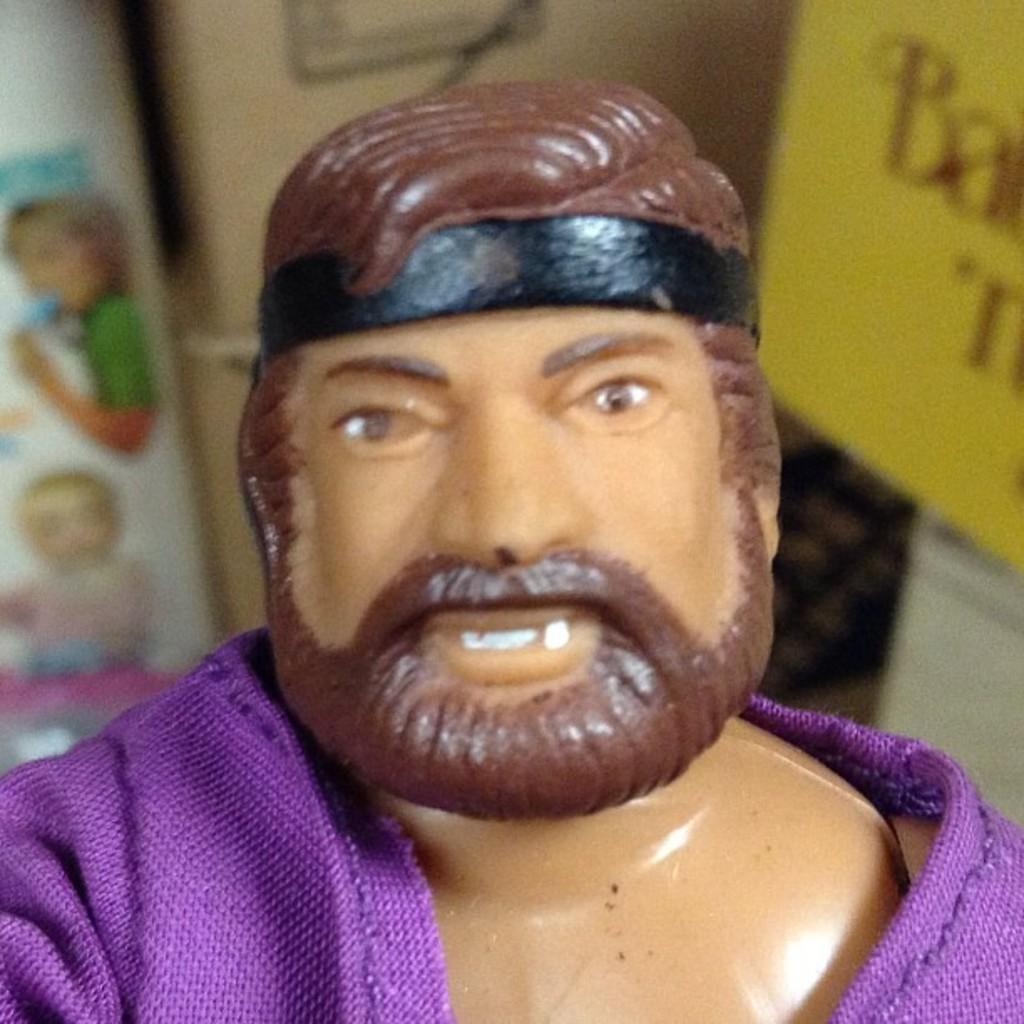What is located in the foreground of the image? There is a toy in the foreground of the image. What can be seen in the background of the image? There are boards and a wall in the background of the image. What type of baseball equipment can be seen in the image? There is no baseball equipment present in the image. Can you describe the kitty playing with the toy in the image? There is no kitty present in the image; it only features a toy in the foreground. 